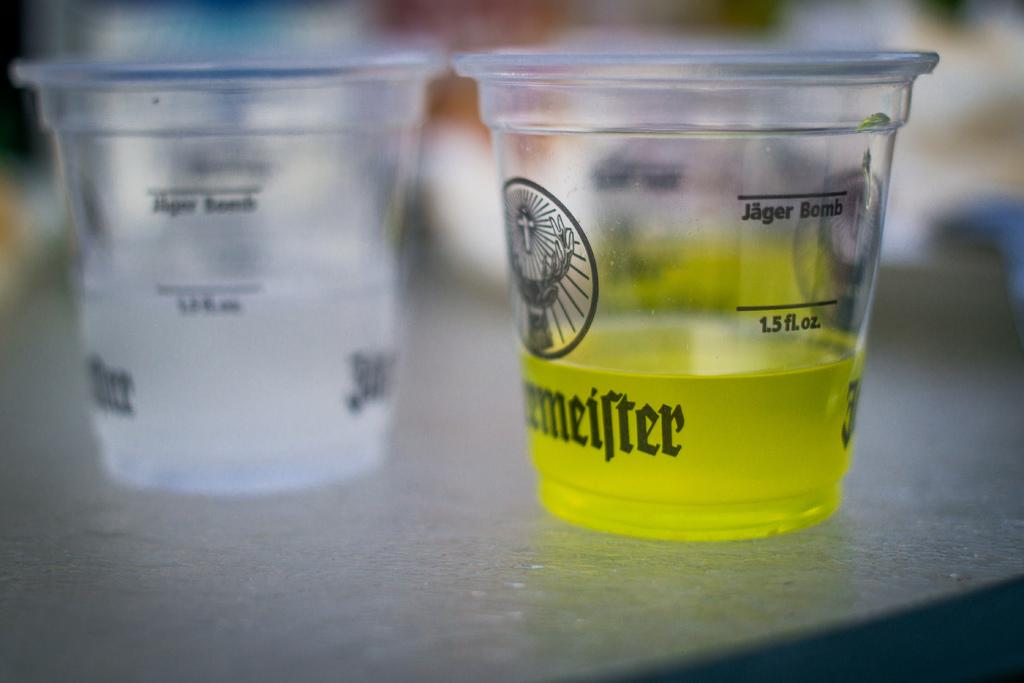Provide a one-sentence caption for the provided image. Two plastic Jagermeister cups and one has a yellow liquid in it. 